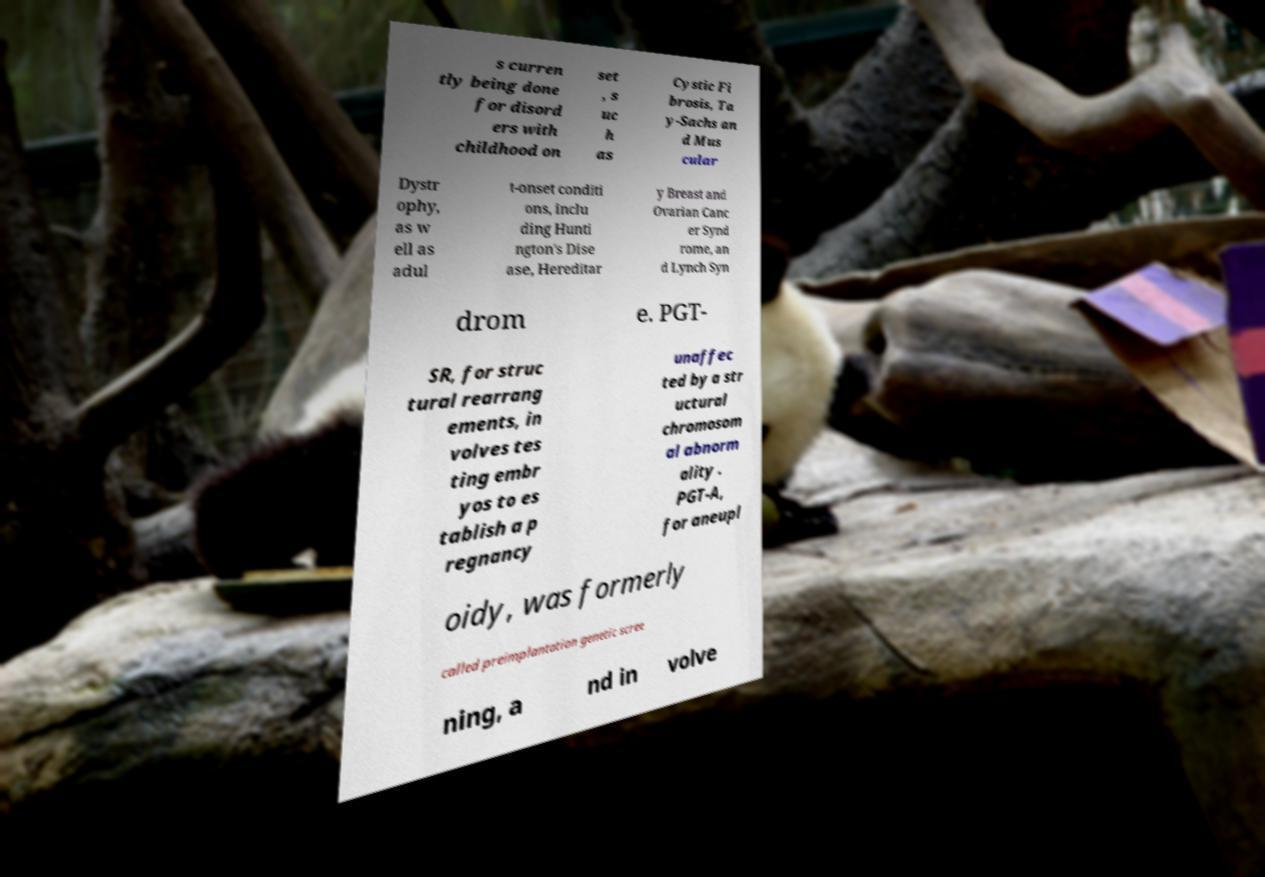What messages or text are displayed in this image? I need them in a readable, typed format. s curren tly being done for disord ers with childhood on set , s uc h as Cystic Fi brosis, Ta y-Sachs an d Mus cular Dystr ophy, as w ell as adul t-onset conditi ons, inclu ding Hunti ngton's Dise ase, Hereditar y Breast and Ovarian Canc er Synd rome, an d Lynch Syn drom e. PGT- SR, for struc tural rearrang ements, in volves tes ting embr yos to es tablish a p regnancy unaffec ted by a str uctural chromosom al abnorm ality . PGT-A, for aneupl oidy, was formerly called preimplantation genetic scree ning, a nd in volve 